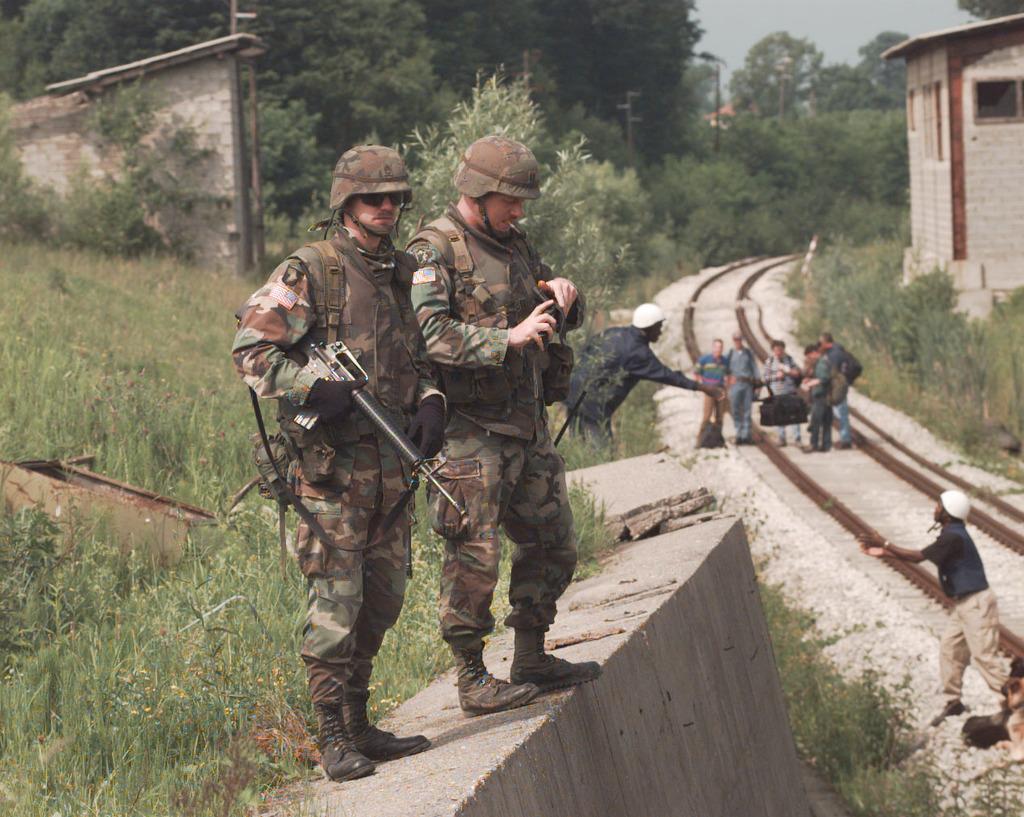Can you describe this image briefly? In the picture we can see two army people are standing on the wall, they are wearing a uniform, helmets and holding guns and besides, we can see a railway track and some people standing on it and in the background also we can see some trees, poles and sky. 